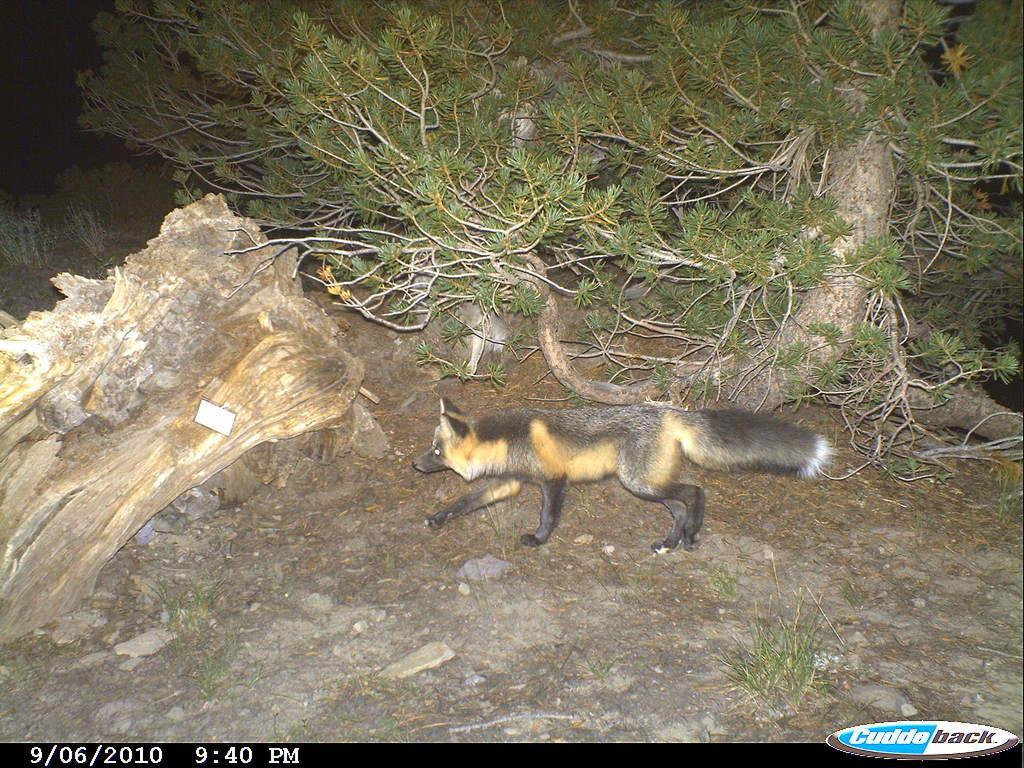Describe this image in one or two sentences. In this image there is an animal walking on the surface, in front of the animal there is a wooden branch, beside that there is a tree. The background is dark. At the bottom of the image there is some text. 